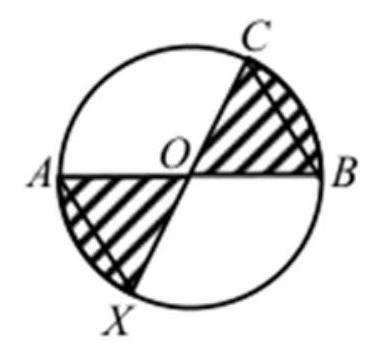Can you explain how the segments and angles relate to each other in this circle? Certainly! In the provided diagram, the circle is intersected by two diameters, AB and CX, forming a right-angle cross as they are perpendicular. Each segment (AB, BC, CO, and OX) forms specific angles at the center and with each other. The triangle OBC is isosceles since OB equals BC, thus angles OBC and BCO are equal, influencing how the area calculations are split among different sections of the circle. 